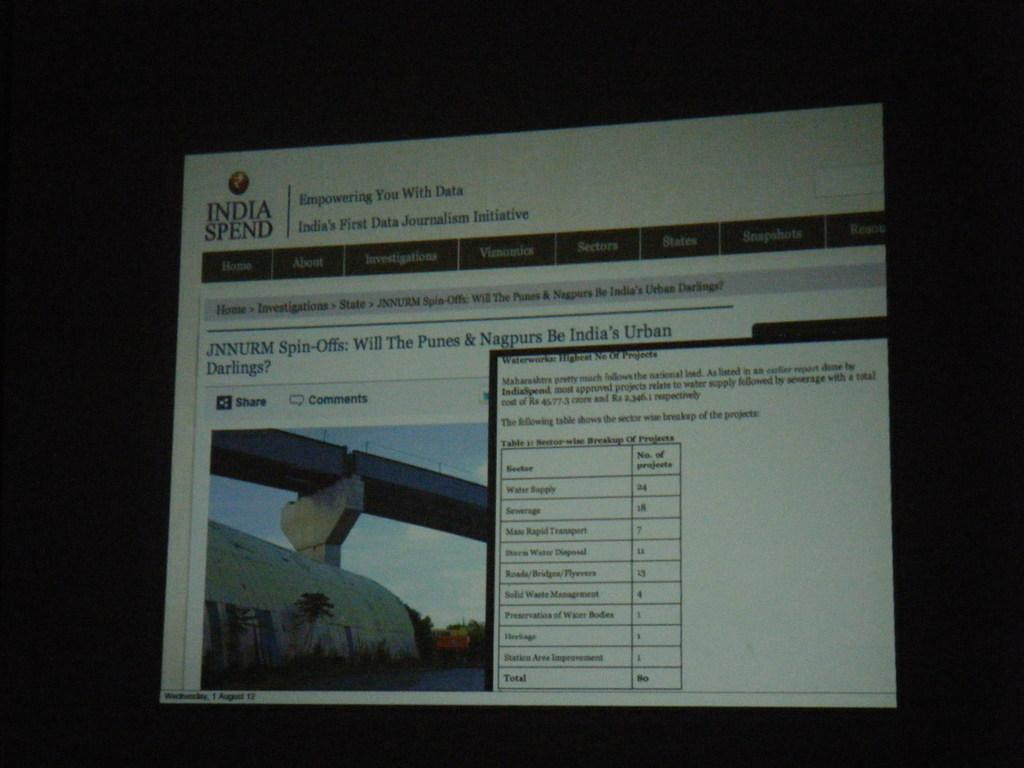Provide a one-sentence caption for the provided image. India Spend page is open and has a lot of imformation available. 